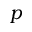Convert formula to latex. <formula><loc_0><loc_0><loc_500><loc_500>p</formula> 